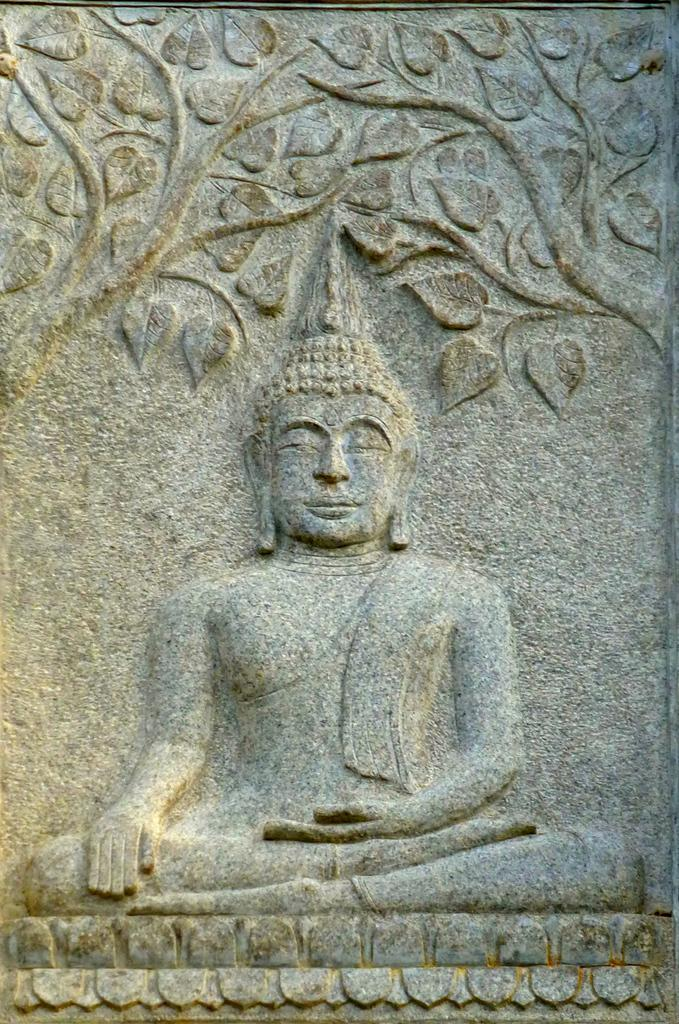What is the main subject in the image? There is a sculpture in the image. What type of pin can be seen attached to the sculpture in the image? There is no pin present on the sculpture in the image. 